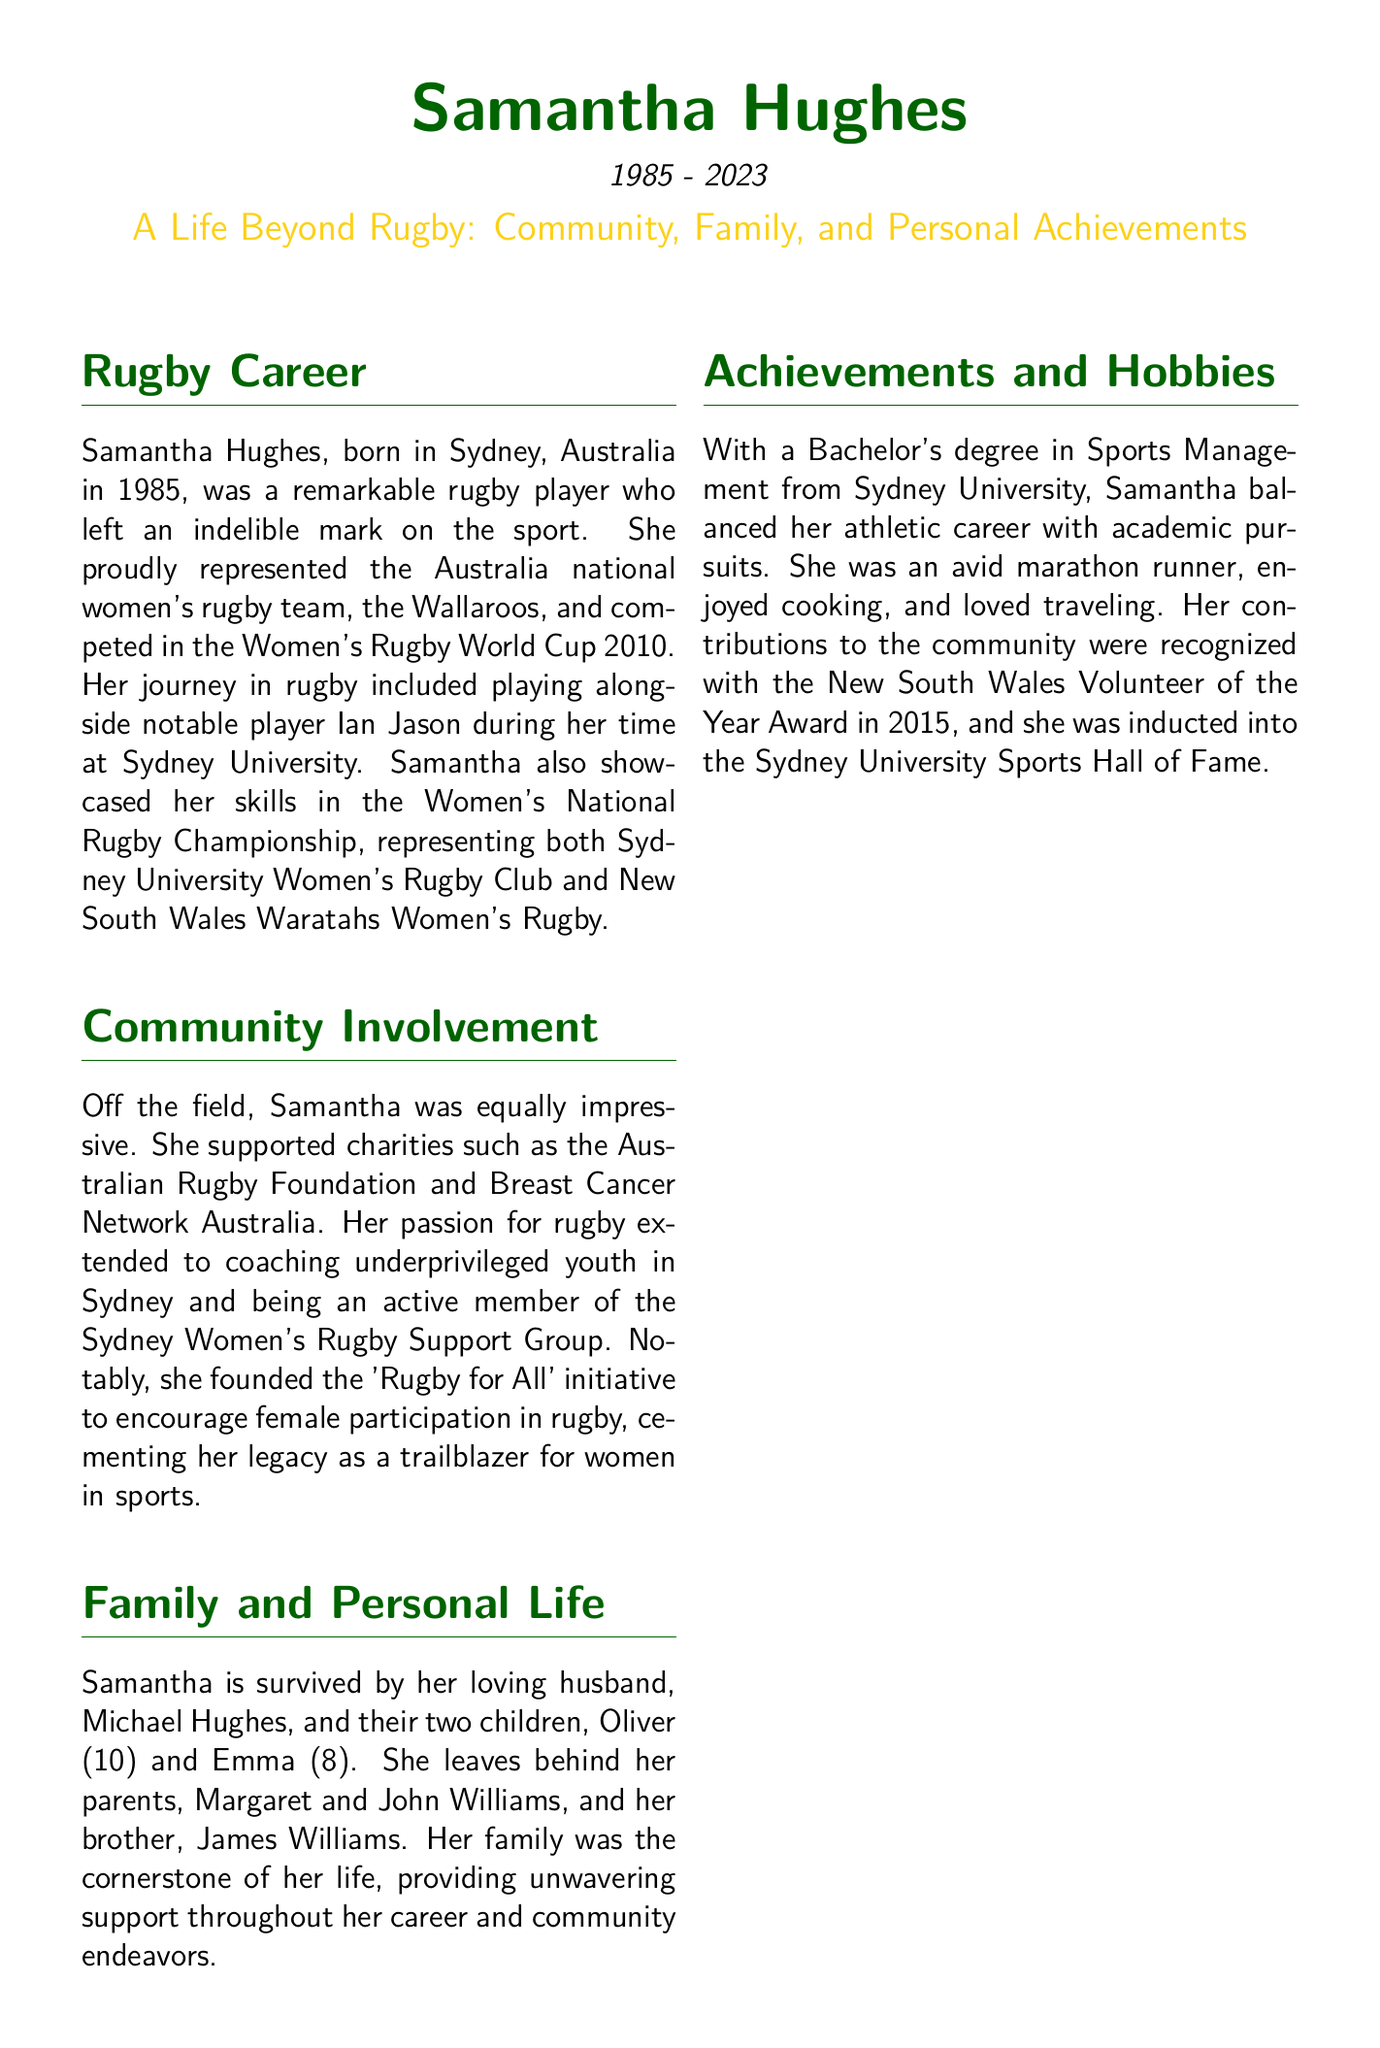What year was Samantha Hughes born? The document states that Samantha Hughes was born in 1985.
Answer: 1985 Which rugby team did Samantha represent? The document mentions that she represented the Australia national women's rugby team, the Wallaroos.
Answer: Wallaroos What initiative did Samantha found to encourage female participation in rugby? The document specifies that she founded the 'Rugby for All' initiative.
Answer: Rugby for All How many children did Samantha have? The document indicates that she had two children, Oliver and Emma.
Answer: Two What award did Samantha receive in 2015? The document states that she was recognized with the New South Wales Volunteer of the Year Award.
Answer: New South Wales Volunteer of the Year Award Who was her husband? The document identifies her husband as Michael Hughes.
Answer: Michael Hughes What was Samantha's degree in? The document states that she had a Bachelor's degree in Sports Management.
Answer: Sports Management What was one of Samantha's hobbies? The document mentions that she was an avid marathon runner as one of her hobbies.
Answer: Marathon runner When did Samantha pass away? The document provides the date range indicating that Samantha passed away in 2023.
Answer: 2023 